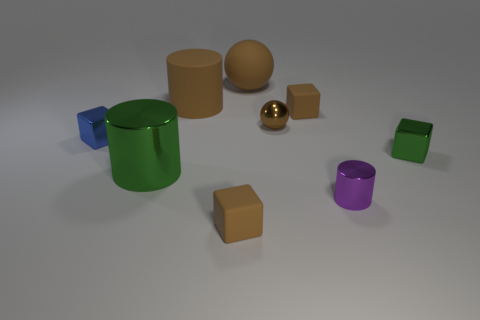Subtract all tiny blue cubes. How many cubes are left? 3 Subtract all brown blocks. How many blocks are left? 2 Subtract all purple cylinders. How many brown blocks are left? 2 Subtract 1 cylinders. How many cylinders are left? 2 Subtract all balls. How many objects are left? 7 Add 1 big green cylinders. How many big green cylinders are left? 2 Add 7 large rubber spheres. How many large rubber spheres exist? 8 Subtract 0 yellow blocks. How many objects are left? 9 Subtract all cyan cylinders. Subtract all gray cubes. How many cylinders are left? 3 Subtract all small green cubes. Subtract all purple cylinders. How many objects are left? 7 